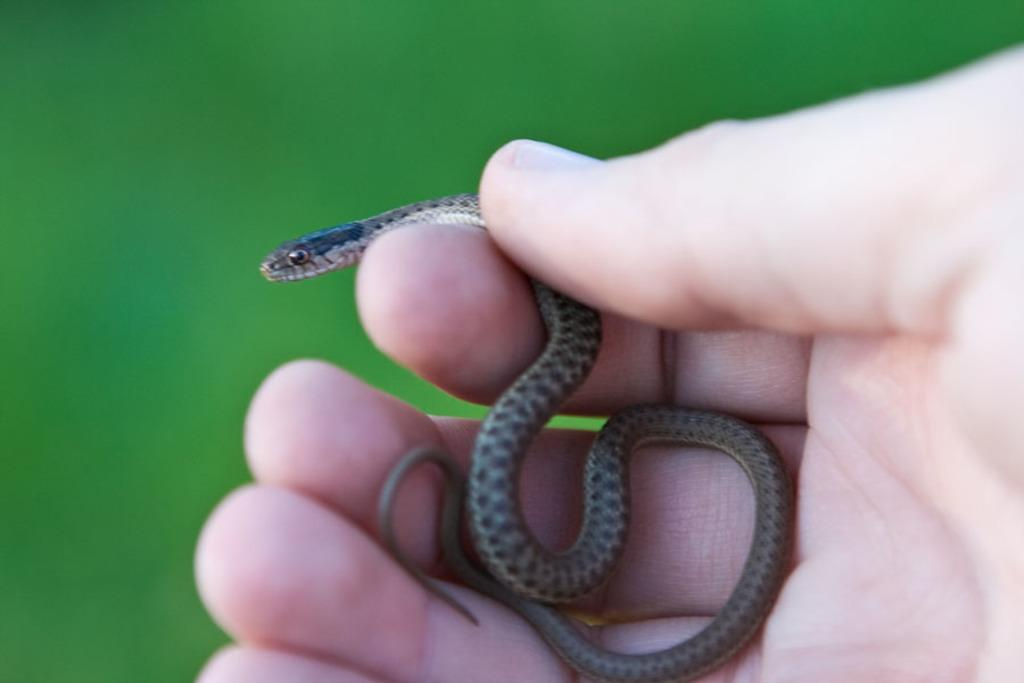What animal is present in the image? There is a snake in the image. Where is the snake located in the image? The snake is in a person's hand. What type of gun is being used to crack the eggs in the image? There is no gun or eggs present in the image; it features a snake and a person's hand. 